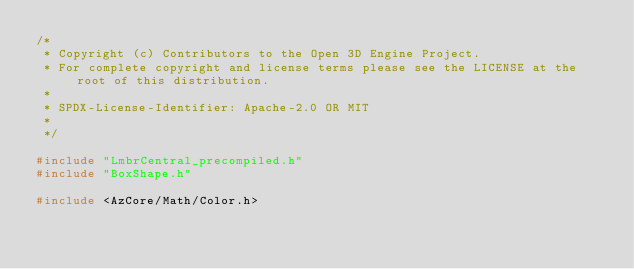Convert code to text. <code><loc_0><loc_0><loc_500><loc_500><_C++_>/*
 * Copyright (c) Contributors to the Open 3D Engine Project.
 * For complete copyright and license terms please see the LICENSE at the root of this distribution.
 *
 * SPDX-License-Identifier: Apache-2.0 OR MIT
 *
 */

#include "LmbrCentral_precompiled.h"
#include "BoxShape.h"

#include <AzCore/Math/Color.h></code> 